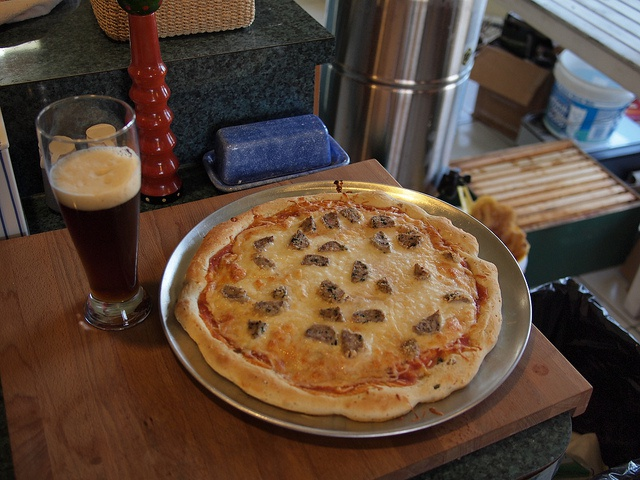Describe the objects in this image and their specific colors. I can see dining table in maroon, brown, black, and tan tones, pizza in maroon, brown, tan, and gray tones, and cup in maroon, black, tan, and gray tones in this image. 